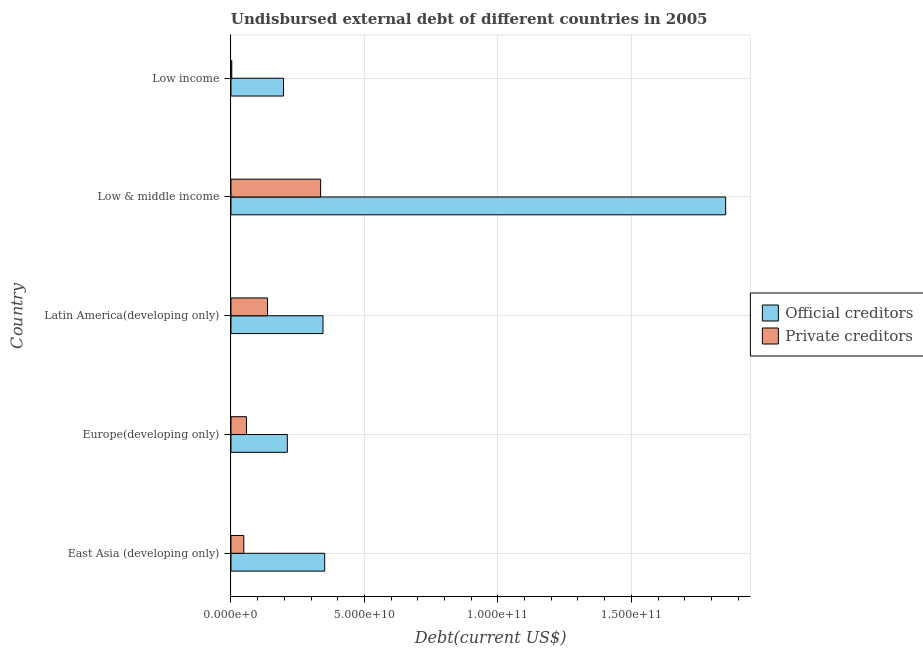Are the number of bars per tick equal to the number of legend labels?
Your response must be concise. Yes. How many bars are there on the 3rd tick from the top?
Offer a terse response. 2. How many bars are there on the 4th tick from the bottom?
Your answer should be very brief. 2. What is the label of the 5th group of bars from the top?
Keep it short and to the point. East Asia (developing only). In how many cases, is the number of bars for a given country not equal to the number of legend labels?
Provide a short and direct response. 0. What is the undisbursed external debt of private creditors in Low income?
Your answer should be compact. 2.95e+08. Across all countries, what is the maximum undisbursed external debt of private creditors?
Your answer should be very brief. 3.36e+1. Across all countries, what is the minimum undisbursed external debt of private creditors?
Keep it short and to the point. 2.95e+08. In which country was the undisbursed external debt of private creditors maximum?
Ensure brevity in your answer.  Low & middle income. What is the total undisbursed external debt of official creditors in the graph?
Offer a very short reply. 2.96e+11. What is the difference between the undisbursed external debt of official creditors in East Asia (developing only) and that in Europe(developing only)?
Provide a short and direct response. 1.40e+1. What is the difference between the undisbursed external debt of official creditors in Low & middle income and the undisbursed external debt of private creditors in Low income?
Give a very brief answer. 1.85e+11. What is the average undisbursed external debt of official creditors per country?
Give a very brief answer. 5.91e+1. What is the difference between the undisbursed external debt of private creditors and undisbursed external debt of official creditors in Latin America(developing only)?
Offer a terse response. -2.08e+1. What is the ratio of the undisbursed external debt of private creditors in Low & middle income to that in Low income?
Give a very brief answer. 113.89. Is the undisbursed external debt of official creditors in East Asia (developing only) less than that in Low income?
Your answer should be compact. No. What is the difference between the highest and the second highest undisbursed external debt of official creditors?
Your answer should be compact. 1.50e+11. What is the difference between the highest and the lowest undisbursed external debt of official creditors?
Make the answer very short. 1.66e+11. What does the 2nd bar from the top in Europe(developing only) represents?
Make the answer very short. Official creditors. What does the 2nd bar from the bottom in Latin America(developing only) represents?
Offer a terse response. Private creditors. How many bars are there?
Offer a terse response. 10. Are all the bars in the graph horizontal?
Your answer should be very brief. Yes. How many countries are there in the graph?
Make the answer very short. 5. Are the values on the major ticks of X-axis written in scientific E-notation?
Ensure brevity in your answer.  Yes. Does the graph contain any zero values?
Your answer should be very brief. No. Does the graph contain grids?
Make the answer very short. Yes. How are the legend labels stacked?
Your response must be concise. Vertical. What is the title of the graph?
Offer a very short reply. Undisbursed external debt of different countries in 2005. Does "Taxes on profits and capital gains" appear as one of the legend labels in the graph?
Provide a short and direct response. No. What is the label or title of the X-axis?
Your response must be concise. Debt(current US$). What is the Debt(current US$) of Official creditors in East Asia (developing only)?
Ensure brevity in your answer.  3.51e+1. What is the Debt(current US$) in Private creditors in East Asia (developing only)?
Ensure brevity in your answer.  4.80e+09. What is the Debt(current US$) in Official creditors in Europe(developing only)?
Your answer should be compact. 2.11e+1. What is the Debt(current US$) of Private creditors in Europe(developing only)?
Give a very brief answer. 5.80e+09. What is the Debt(current US$) of Official creditors in Latin America(developing only)?
Give a very brief answer. 3.45e+1. What is the Debt(current US$) in Private creditors in Latin America(developing only)?
Keep it short and to the point. 1.37e+1. What is the Debt(current US$) in Official creditors in Low & middle income?
Your response must be concise. 1.85e+11. What is the Debt(current US$) of Private creditors in Low & middle income?
Ensure brevity in your answer.  3.36e+1. What is the Debt(current US$) in Official creditors in Low income?
Offer a terse response. 1.97e+1. What is the Debt(current US$) of Private creditors in Low income?
Your answer should be very brief. 2.95e+08. Across all countries, what is the maximum Debt(current US$) of Official creditors?
Offer a terse response. 1.85e+11. Across all countries, what is the maximum Debt(current US$) in Private creditors?
Provide a short and direct response. 3.36e+1. Across all countries, what is the minimum Debt(current US$) in Official creditors?
Offer a very short reply. 1.97e+1. Across all countries, what is the minimum Debt(current US$) of Private creditors?
Provide a succinct answer. 2.95e+08. What is the total Debt(current US$) of Official creditors in the graph?
Provide a short and direct response. 2.96e+11. What is the total Debt(current US$) of Private creditors in the graph?
Keep it short and to the point. 5.82e+1. What is the difference between the Debt(current US$) in Official creditors in East Asia (developing only) and that in Europe(developing only)?
Make the answer very short. 1.40e+1. What is the difference between the Debt(current US$) in Private creditors in East Asia (developing only) and that in Europe(developing only)?
Your answer should be compact. -1.00e+09. What is the difference between the Debt(current US$) of Official creditors in East Asia (developing only) and that in Latin America(developing only)?
Ensure brevity in your answer.  6.19e+08. What is the difference between the Debt(current US$) in Private creditors in East Asia (developing only) and that in Latin America(developing only)?
Offer a very short reply. -8.89e+09. What is the difference between the Debt(current US$) in Official creditors in East Asia (developing only) and that in Low & middle income?
Your answer should be very brief. -1.50e+11. What is the difference between the Debt(current US$) in Private creditors in East Asia (developing only) and that in Low & middle income?
Your answer should be very brief. -2.88e+1. What is the difference between the Debt(current US$) of Official creditors in East Asia (developing only) and that in Low income?
Your answer should be very brief. 1.54e+1. What is the difference between the Debt(current US$) of Private creditors in East Asia (developing only) and that in Low income?
Offer a very short reply. 4.51e+09. What is the difference between the Debt(current US$) in Official creditors in Europe(developing only) and that in Latin America(developing only)?
Your response must be concise. -1.34e+1. What is the difference between the Debt(current US$) of Private creditors in Europe(developing only) and that in Latin America(developing only)?
Provide a short and direct response. -7.89e+09. What is the difference between the Debt(current US$) in Official creditors in Europe(developing only) and that in Low & middle income?
Your response must be concise. -1.64e+11. What is the difference between the Debt(current US$) of Private creditors in Europe(developing only) and that in Low & middle income?
Offer a terse response. -2.78e+1. What is the difference between the Debt(current US$) in Official creditors in Europe(developing only) and that in Low income?
Ensure brevity in your answer.  1.43e+09. What is the difference between the Debt(current US$) in Private creditors in Europe(developing only) and that in Low income?
Your answer should be compact. 5.51e+09. What is the difference between the Debt(current US$) of Official creditors in Latin America(developing only) and that in Low & middle income?
Your answer should be very brief. -1.51e+11. What is the difference between the Debt(current US$) in Private creditors in Latin America(developing only) and that in Low & middle income?
Your answer should be very brief. -1.99e+1. What is the difference between the Debt(current US$) in Official creditors in Latin America(developing only) and that in Low income?
Give a very brief answer. 1.48e+1. What is the difference between the Debt(current US$) of Private creditors in Latin America(developing only) and that in Low income?
Your answer should be very brief. 1.34e+1. What is the difference between the Debt(current US$) of Official creditors in Low & middle income and that in Low income?
Give a very brief answer. 1.66e+11. What is the difference between the Debt(current US$) of Private creditors in Low & middle income and that in Low income?
Offer a very short reply. 3.33e+1. What is the difference between the Debt(current US$) of Official creditors in East Asia (developing only) and the Debt(current US$) of Private creditors in Europe(developing only)?
Ensure brevity in your answer.  2.93e+1. What is the difference between the Debt(current US$) of Official creditors in East Asia (developing only) and the Debt(current US$) of Private creditors in Latin America(developing only)?
Your answer should be compact. 2.14e+1. What is the difference between the Debt(current US$) of Official creditors in East Asia (developing only) and the Debt(current US$) of Private creditors in Low & middle income?
Offer a terse response. 1.51e+09. What is the difference between the Debt(current US$) of Official creditors in East Asia (developing only) and the Debt(current US$) of Private creditors in Low income?
Give a very brief answer. 3.48e+1. What is the difference between the Debt(current US$) in Official creditors in Europe(developing only) and the Debt(current US$) in Private creditors in Latin America(developing only)?
Provide a succinct answer. 7.42e+09. What is the difference between the Debt(current US$) in Official creditors in Europe(developing only) and the Debt(current US$) in Private creditors in Low & middle income?
Your response must be concise. -1.25e+1. What is the difference between the Debt(current US$) in Official creditors in Europe(developing only) and the Debt(current US$) in Private creditors in Low income?
Make the answer very short. 2.08e+1. What is the difference between the Debt(current US$) of Official creditors in Latin America(developing only) and the Debt(current US$) of Private creditors in Low & middle income?
Keep it short and to the point. 8.96e+08. What is the difference between the Debt(current US$) of Official creditors in Latin America(developing only) and the Debt(current US$) of Private creditors in Low income?
Offer a terse response. 3.42e+1. What is the difference between the Debt(current US$) in Official creditors in Low & middle income and the Debt(current US$) in Private creditors in Low income?
Provide a succinct answer. 1.85e+11. What is the average Debt(current US$) in Official creditors per country?
Offer a very short reply. 5.91e+1. What is the average Debt(current US$) of Private creditors per country?
Give a very brief answer. 1.16e+1. What is the difference between the Debt(current US$) in Official creditors and Debt(current US$) in Private creditors in East Asia (developing only)?
Ensure brevity in your answer.  3.03e+1. What is the difference between the Debt(current US$) in Official creditors and Debt(current US$) in Private creditors in Europe(developing only)?
Offer a very short reply. 1.53e+1. What is the difference between the Debt(current US$) of Official creditors and Debt(current US$) of Private creditors in Latin America(developing only)?
Your answer should be compact. 2.08e+1. What is the difference between the Debt(current US$) in Official creditors and Debt(current US$) in Private creditors in Low & middle income?
Your answer should be compact. 1.52e+11. What is the difference between the Debt(current US$) in Official creditors and Debt(current US$) in Private creditors in Low income?
Provide a short and direct response. 1.94e+1. What is the ratio of the Debt(current US$) of Official creditors in East Asia (developing only) to that in Europe(developing only)?
Give a very brief answer. 1.66. What is the ratio of the Debt(current US$) in Private creditors in East Asia (developing only) to that in Europe(developing only)?
Provide a succinct answer. 0.83. What is the ratio of the Debt(current US$) of Private creditors in East Asia (developing only) to that in Latin America(developing only)?
Your answer should be compact. 0.35. What is the ratio of the Debt(current US$) of Official creditors in East Asia (developing only) to that in Low & middle income?
Give a very brief answer. 0.19. What is the ratio of the Debt(current US$) in Private creditors in East Asia (developing only) to that in Low & middle income?
Provide a short and direct response. 0.14. What is the ratio of the Debt(current US$) in Official creditors in East Asia (developing only) to that in Low income?
Your answer should be very brief. 1.78. What is the ratio of the Debt(current US$) in Private creditors in East Asia (developing only) to that in Low income?
Offer a terse response. 16.28. What is the ratio of the Debt(current US$) in Official creditors in Europe(developing only) to that in Latin America(developing only)?
Your response must be concise. 0.61. What is the ratio of the Debt(current US$) of Private creditors in Europe(developing only) to that in Latin America(developing only)?
Ensure brevity in your answer.  0.42. What is the ratio of the Debt(current US$) in Official creditors in Europe(developing only) to that in Low & middle income?
Provide a short and direct response. 0.11. What is the ratio of the Debt(current US$) in Private creditors in Europe(developing only) to that in Low & middle income?
Offer a very short reply. 0.17. What is the ratio of the Debt(current US$) of Official creditors in Europe(developing only) to that in Low income?
Offer a very short reply. 1.07. What is the ratio of the Debt(current US$) of Private creditors in Europe(developing only) to that in Low income?
Your response must be concise. 19.67. What is the ratio of the Debt(current US$) in Official creditors in Latin America(developing only) to that in Low & middle income?
Make the answer very short. 0.19. What is the ratio of the Debt(current US$) in Private creditors in Latin America(developing only) to that in Low & middle income?
Keep it short and to the point. 0.41. What is the ratio of the Debt(current US$) of Official creditors in Latin America(developing only) to that in Low income?
Ensure brevity in your answer.  1.75. What is the ratio of the Debt(current US$) of Private creditors in Latin America(developing only) to that in Low income?
Your answer should be compact. 46.43. What is the ratio of the Debt(current US$) of Official creditors in Low & middle income to that in Low income?
Give a very brief answer. 9.42. What is the ratio of the Debt(current US$) in Private creditors in Low & middle income to that in Low income?
Your answer should be very brief. 113.89. What is the difference between the highest and the second highest Debt(current US$) in Official creditors?
Provide a short and direct response. 1.50e+11. What is the difference between the highest and the second highest Debt(current US$) of Private creditors?
Provide a short and direct response. 1.99e+1. What is the difference between the highest and the lowest Debt(current US$) in Official creditors?
Ensure brevity in your answer.  1.66e+11. What is the difference between the highest and the lowest Debt(current US$) in Private creditors?
Offer a terse response. 3.33e+1. 